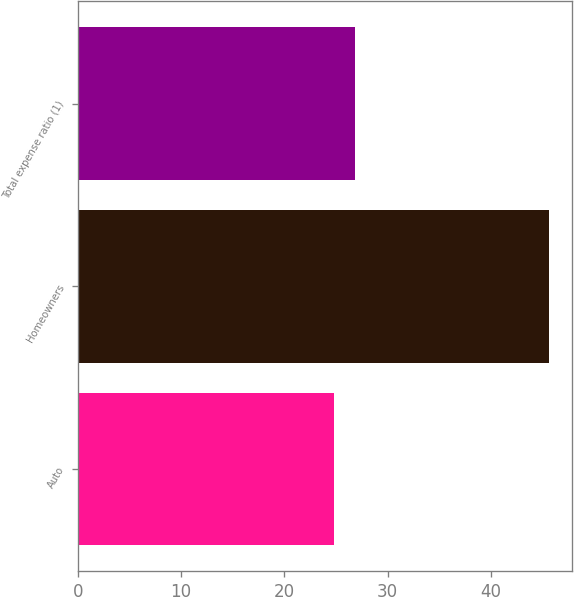Convert chart. <chart><loc_0><loc_0><loc_500><loc_500><bar_chart><fcel>Auto<fcel>Homeowners<fcel>Total expense ratio (1)<nl><fcel>24.8<fcel>45.6<fcel>26.88<nl></chart> 